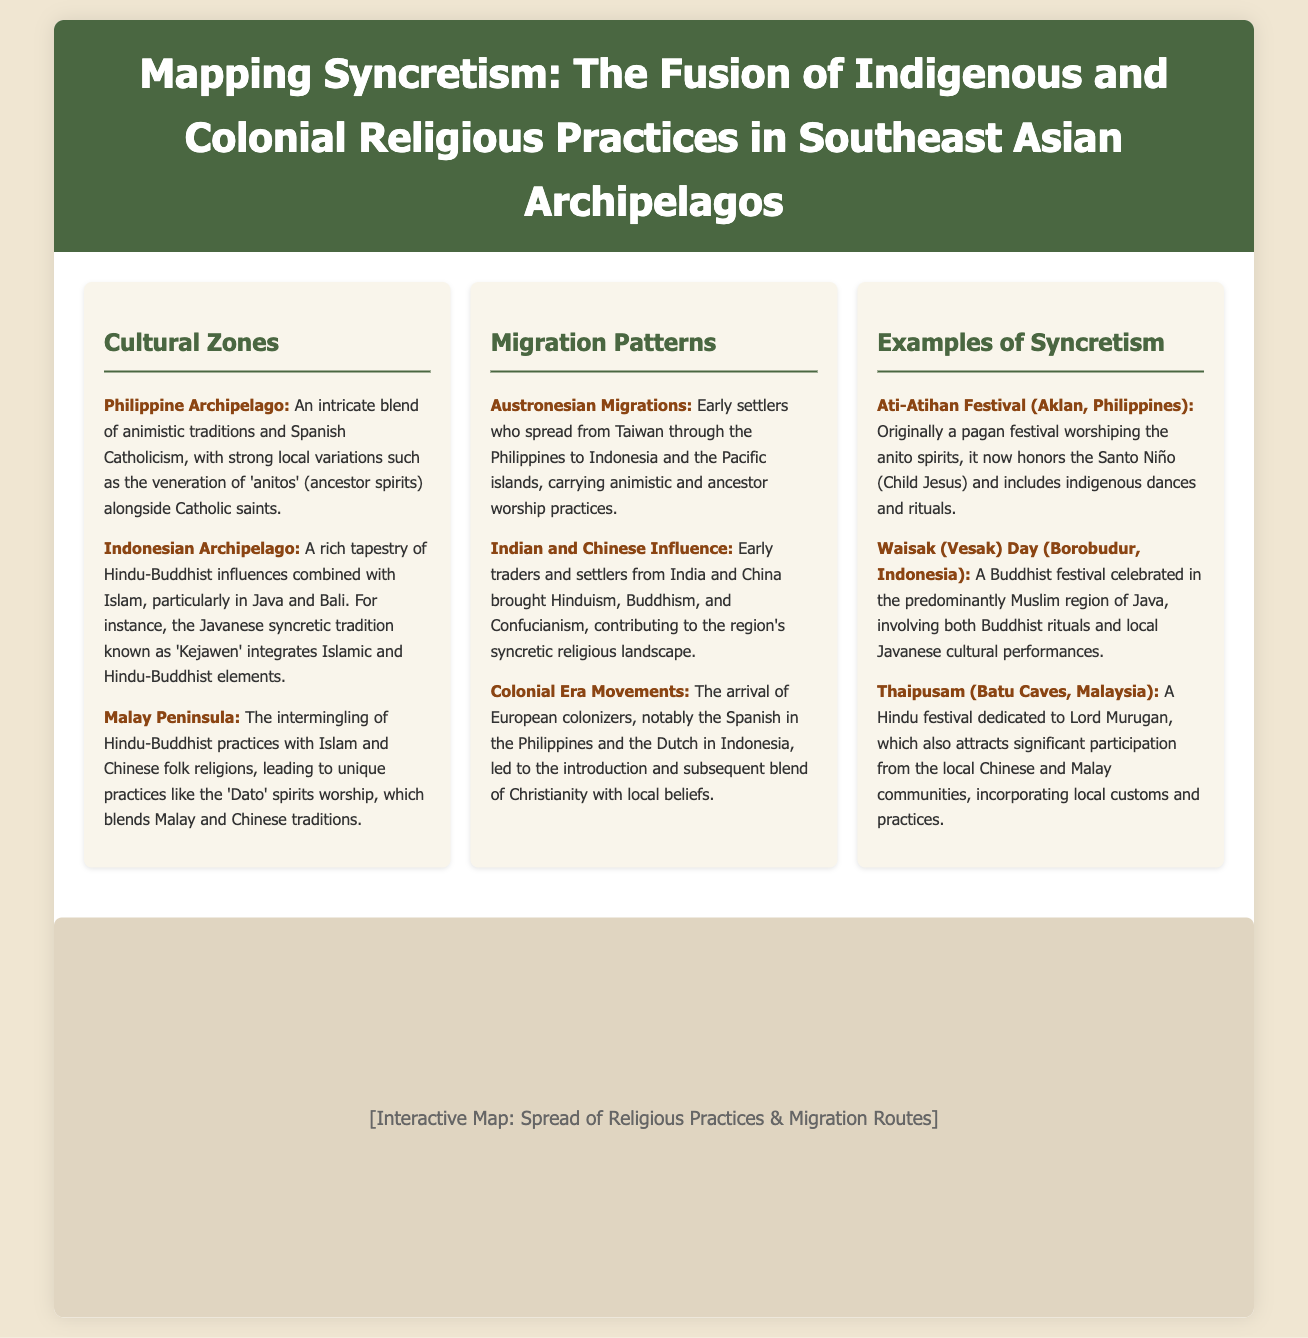what are the main cultural zones mentioned? The document lists specific cultural zones in Southeast Asia, including the Philippine Archipelago, Indonesian Archipelago, and Malay Peninsula.
Answer: Philippine Archipelago, Indonesian Archipelago, Malay Peninsula what notable festival blends indigenous and colonial practices in the Philippines? The Ati-Atihan Festival is highlighted as a fusion of indigenous worship and Catholicism.
Answer: Ati-Atihan Festival which syncretic tradition integrates Islamic and Hindu-Buddhist elements in Java? The document refers to a specific syncretic tradition known as 'Kejawen' that embodies this blend.
Answer: Kejawen what type of migrations contributed significantly to the religious landscape in Southeast Asia? The document mentions Austronesian migrations as a primary early influence.
Answer: Austronesian Migrations which colonial power is associated with introducing Christianity in the Philippines? According to the document, the Spanish were the key colonial power in the Philippines that introduced Christianity.
Answer: Spanish what local Javanese cultural performance is incorporated during the Waisak Day festival? The document indicates the involvement of local Javanese cultural performances during Waisak Day.
Answer: Javanese cultural performances who is worshiped during the Thaipusam festival? The Thaipusam festival is dedicated to Lord Murugan according to the document.
Answer: Lord Murugan what influences did Indian and Chinese settlers bring to Southeast Asia? The document states that these settlers contributed Hinduism, Buddhism, and Confucianism to the region.
Answer: Hinduism, Buddhism, Confucianism 